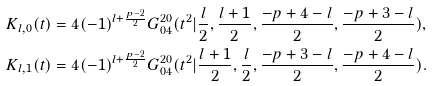Convert formula to latex. <formula><loc_0><loc_0><loc_500><loc_500>& K _ { l , 0 } ( t ) = 4 ( - 1 ) ^ { l + \frac { p - 2 } 2 } G _ { 0 4 } ^ { 2 0 } ( t ^ { 2 } | \frac { l } 2 , \frac { l + 1 } 2 , \frac { - p + 4 - l } 2 , \frac { - p + 3 - l } 2 ) , \\ & K _ { l , 1 } ( t ) = 4 ( - 1 ) ^ { l + \frac { p - 2 } 2 } G _ { 0 4 } ^ { 2 0 } ( t ^ { 2 } | \frac { l + 1 } 2 , \frac { l } { 2 } , \frac { - p + 3 - l } 2 , \frac { - p + 4 - l } 2 ) .</formula> 